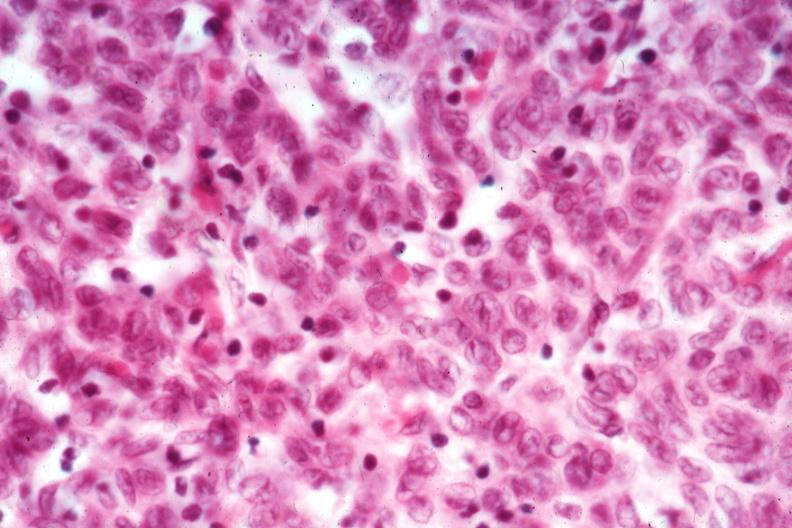s thymus present?
Answer the question using a single word or phrase. Yes 